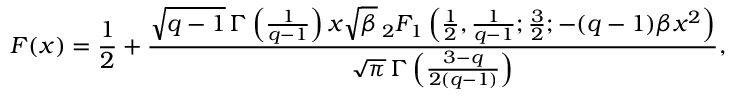Convert formula to latex. <formula><loc_0><loc_0><loc_500><loc_500>F ( x ) = { \frac { 1 } { 2 } } + { \frac { { \sqrt { q - 1 } } \, \Gamma \left ( { \frac { 1 } { q - 1 } } \right ) x { \sqrt { \beta } } \, _ { 2 } F _ { 1 } \left ( { \frac { 1 } { 2 } } , { \frac { 1 } { q - 1 } } ; { \frac { 3 } { 2 } } ; - ( q - 1 ) \beta x ^ { 2 } \right ) } { { \sqrt { \pi } } \, \Gamma \left ( { \frac { 3 - q } { 2 ( q - 1 ) } } \right ) } } ,</formula> 